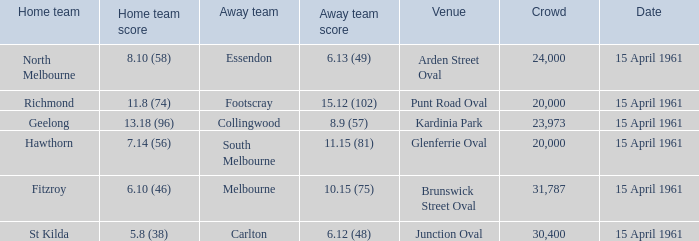What was the score for the home team St Kilda? 5.8 (38). 